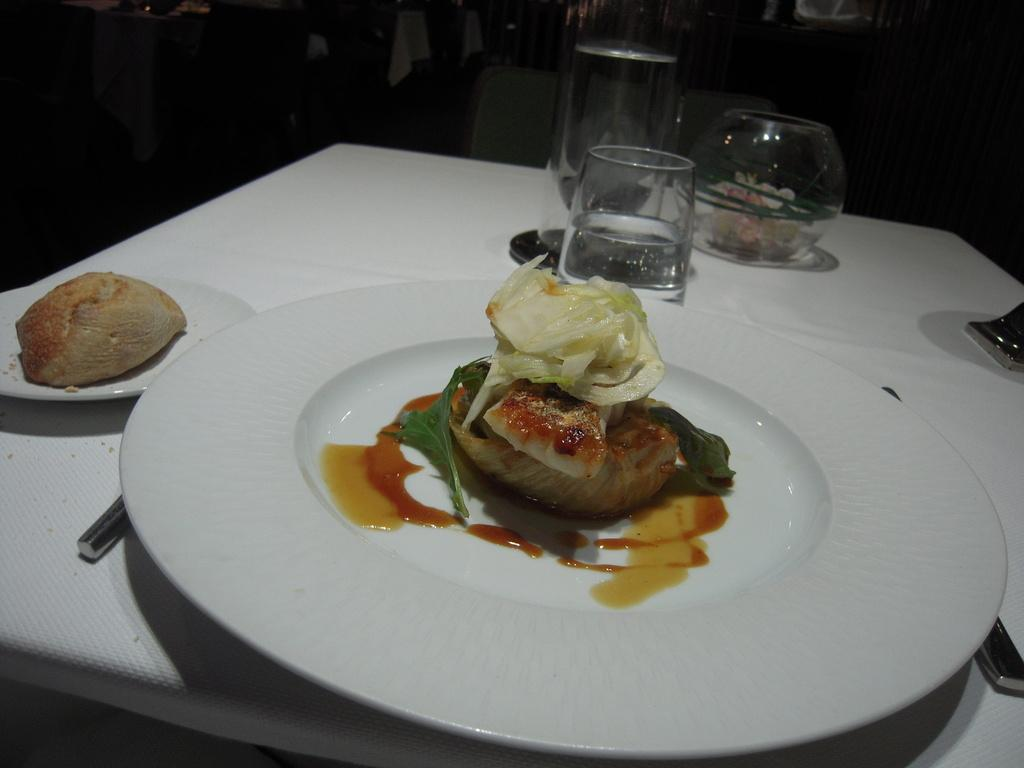What is the main piece of furniture in the image? There is a table in the image. What items are placed on the table? Glasses, plates, and spoons are placed on the table. What is on the plates? Food is present on the plates. What can be seen in the background of the image? Chairs are visible in the background of the image. What type of quartz is used as a centerpiece on the table in the image? There is no quartz present in the image; it features a table with glasses, plates, spoons, and food. How much interest is being charged on the plates in the image? There is no mention of interest or any financial transactions in the image; it simply shows a table with various items. 